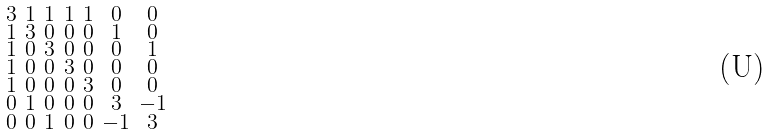Convert formula to latex. <formula><loc_0><loc_0><loc_500><loc_500>\begin{smallmatrix} 3 & 1 & 1 & 1 & 1 & 0 & 0 \\ 1 & 3 & 0 & 0 & 0 & 1 & 0 \\ 1 & 0 & 3 & 0 & 0 & 0 & 1 \\ 1 & 0 & 0 & 3 & 0 & 0 & 0 \\ 1 & 0 & 0 & 0 & 3 & 0 & 0 \\ 0 & 1 & 0 & 0 & 0 & 3 & - 1 \\ 0 & 0 & 1 & 0 & 0 & - 1 & 3 \end{smallmatrix}</formula> 